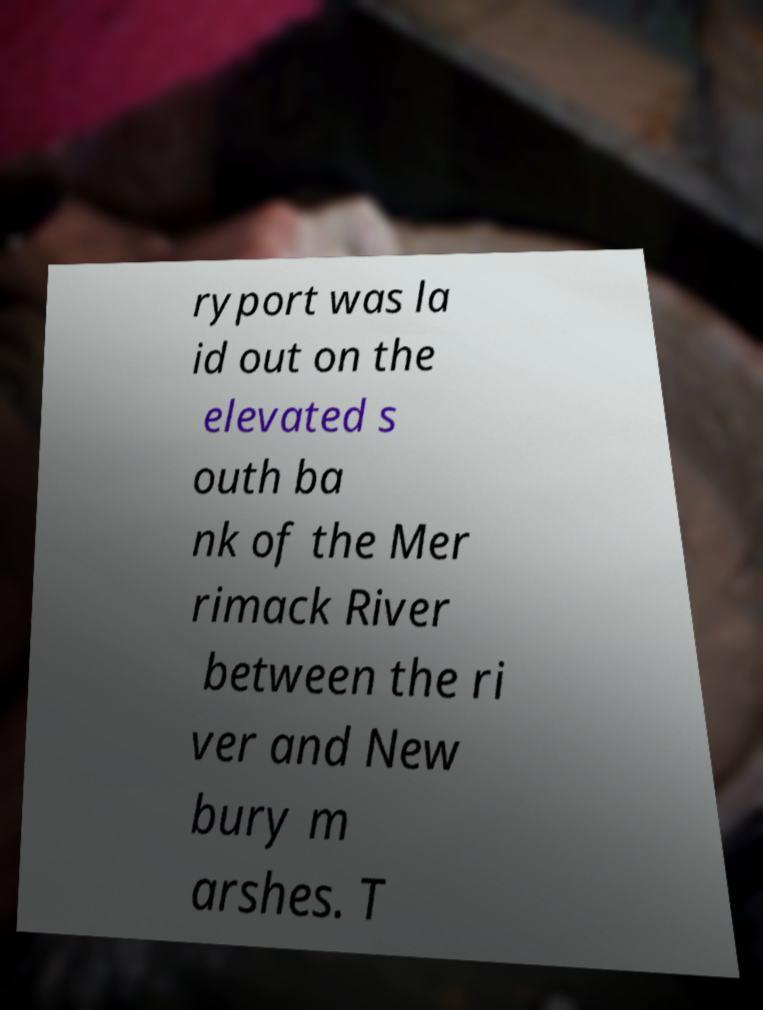Please identify and transcribe the text found in this image. ryport was la id out on the elevated s outh ba nk of the Mer rimack River between the ri ver and New bury m arshes. T 